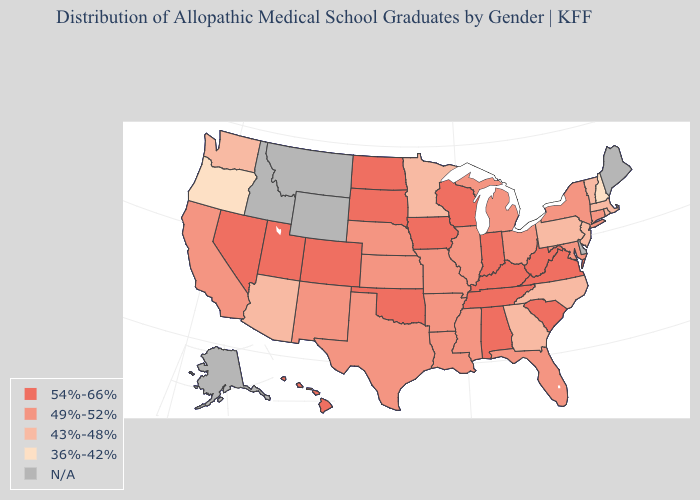What is the highest value in states that border New Jersey?
Be succinct. 49%-52%. What is the value of Georgia?
Give a very brief answer. 43%-48%. What is the highest value in the USA?
Short answer required. 54%-66%. What is the value of Pennsylvania?
Give a very brief answer. 43%-48%. What is the lowest value in states that border Tennessee?
Give a very brief answer. 43%-48%. What is the lowest value in the USA?
Short answer required. 36%-42%. Name the states that have a value in the range 54%-66%?
Keep it brief. Alabama, Colorado, Hawaii, Indiana, Iowa, Kentucky, Nevada, North Dakota, Oklahoma, South Carolina, South Dakota, Tennessee, Utah, Virginia, West Virginia, Wisconsin. Which states hav the highest value in the West?
Answer briefly. Colorado, Hawaii, Nevada, Utah. What is the value of Wyoming?
Quick response, please. N/A. What is the highest value in states that border Vermont?
Write a very short answer. 49%-52%. What is the value of Connecticut?
Answer briefly. 49%-52%. Name the states that have a value in the range 43%-48%?
Keep it brief. Arizona, Georgia, Massachusetts, Minnesota, New Jersey, North Carolina, Pennsylvania, Rhode Island, Vermont, Washington. What is the value of Mississippi?
Be succinct. 49%-52%. Does Missouri have the highest value in the USA?
Give a very brief answer. No. 